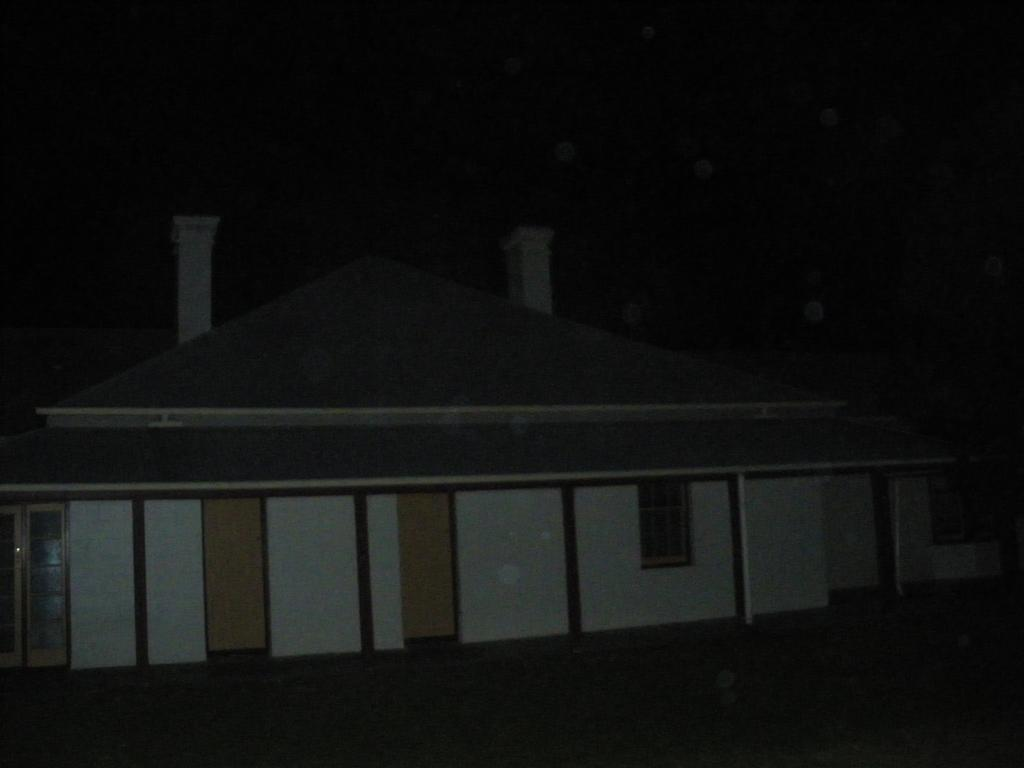What time of day is depicted in the image? The image is taken at night. What is the main subject in the image? There is a house in the middle of the image. Where is the door located on the house? The door is on the left side bottom of the house. Where is the window located on the house? The window is on the right side of the house. How does the pollution increase in the image? There is no mention of pollution in the image, so it cannot be determined if it increases or not. 